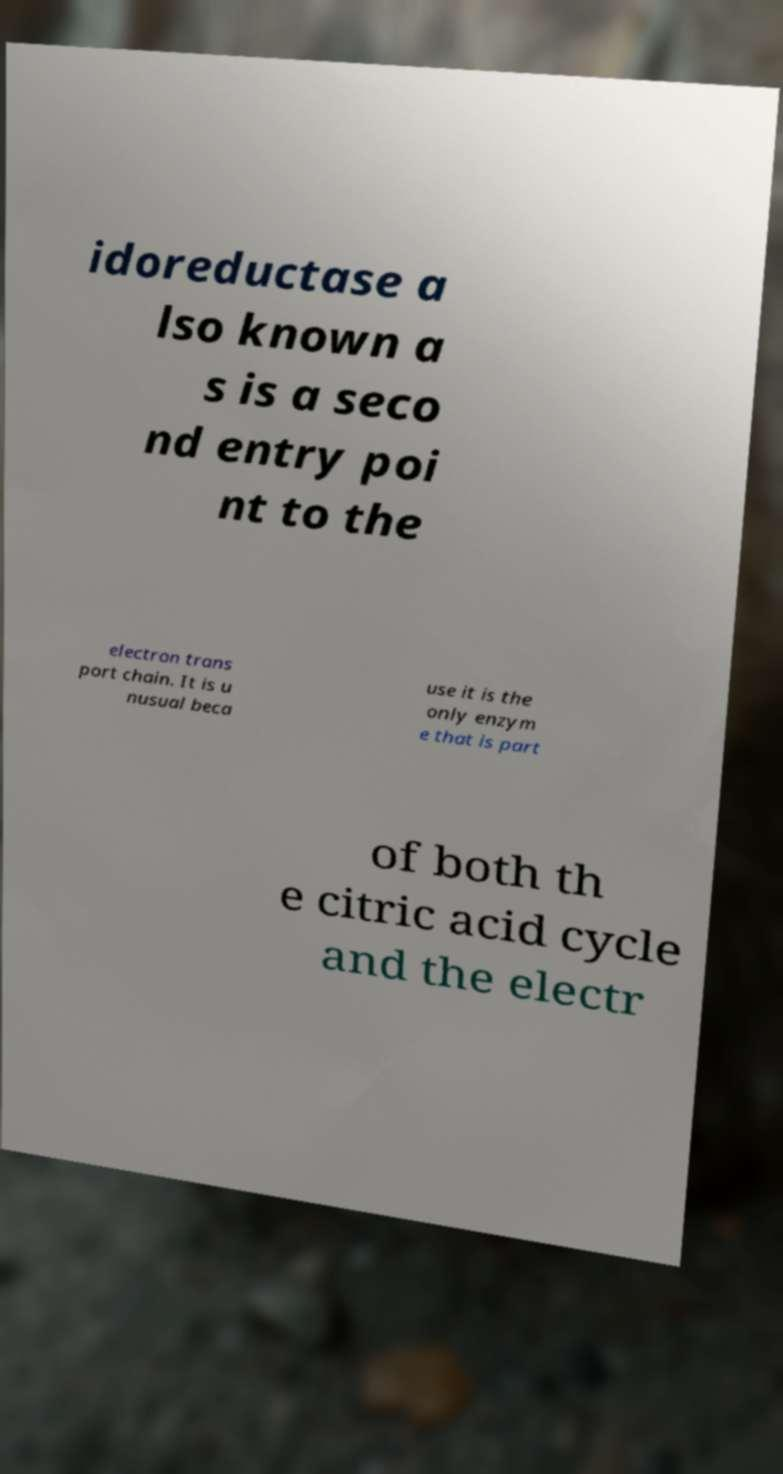Please read and relay the text visible in this image. What does it say? idoreductase a lso known a s is a seco nd entry poi nt to the electron trans port chain. It is u nusual beca use it is the only enzym e that is part of both th e citric acid cycle and the electr 